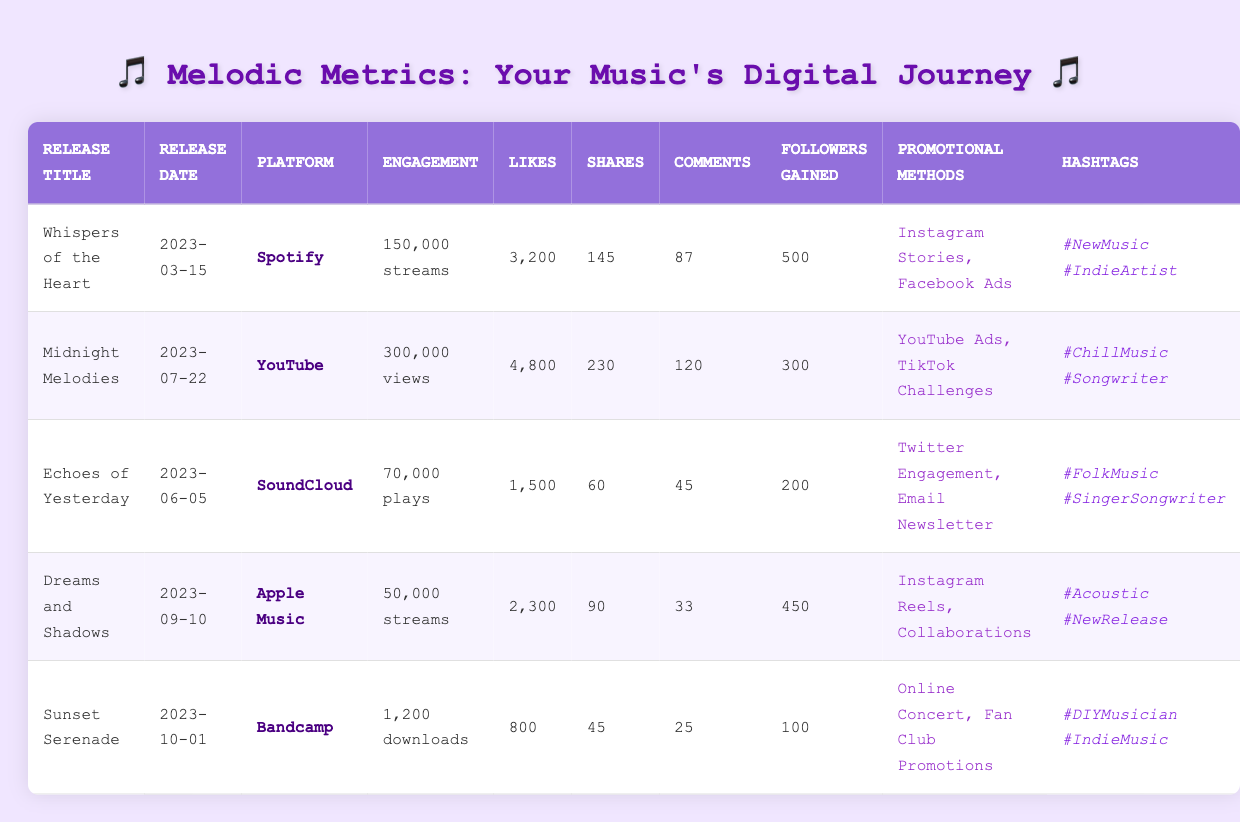What is the total number of likes across all music releases? To find the total number of likes, we sum the likes for each release: 3200 + 4800 + 1500 + 2300 + 800 = 11500.
Answer: 11500 Which release has the highest engagement metrics? "Midnight Melodies" has the highest engagement with 300,000 views, the highest likes at 4800, and 230 shares, making it the standout release in overall engagement metrics.
Answer: Midnight Melodies How many total followers were gained from all releases combined? We add the followers gained from each release: 500 + 300 + 200 + 450 + 100 = 1550 followers gained.
Answer: 1550 Did "Sunset Serenade" perform better in terms of downloads or likes? "Sunset Serenade" had 1200 downloads and 800 likes. Since 1200 > 800, it performed better in downloads compared to likes.
Answer: Yes, it performed better in downloads What is the average number of comments per release? The total number of comments is 87 + 120 + 45 + 33 + 25 = 310. There are 5 releases, so the average is 310 / 5 = 62.
Answer: 62 Which platform had the least amount of engagement based on the data? By comparing, "Apple Music" has the least engagement with 50,000 streams, which is less than all other platforms.
Answer: Apple Music How many more streams did "Whispers of the Heart" have than "Dreams and Shadows"? "Whispers of the Heart" had 150,000 streams and "Dreams and Shadows" had 50,000 streams. The difference is 150,000 - 50,000 = 100,000.
Answer: 100000 List the promotional methods used for "Echoes of Yesterday." The promotional methods listed for "Echoes of Yesterday" are "Twitter Engagement" and "Email Newsletter."
Answer: Twitter Engagement, Email Newsletter For which release were the most shares observed? "Midnight Melodies" had the most shares with a total of 230 shares, more than any other release.
Answer: Midnight Melodies What is the total number of streams and views for all releases? We sum streams and views: 150,000 + 300,000 + 70,000 + 50,000 + 1200 = 571,200.
Answer: 571200 Was "Instagram Stories" used in any of the promotional methods? Yes, "Instagram Stories" was used as a promotional method for "Whispers of the Heart."
Answer: Yes 